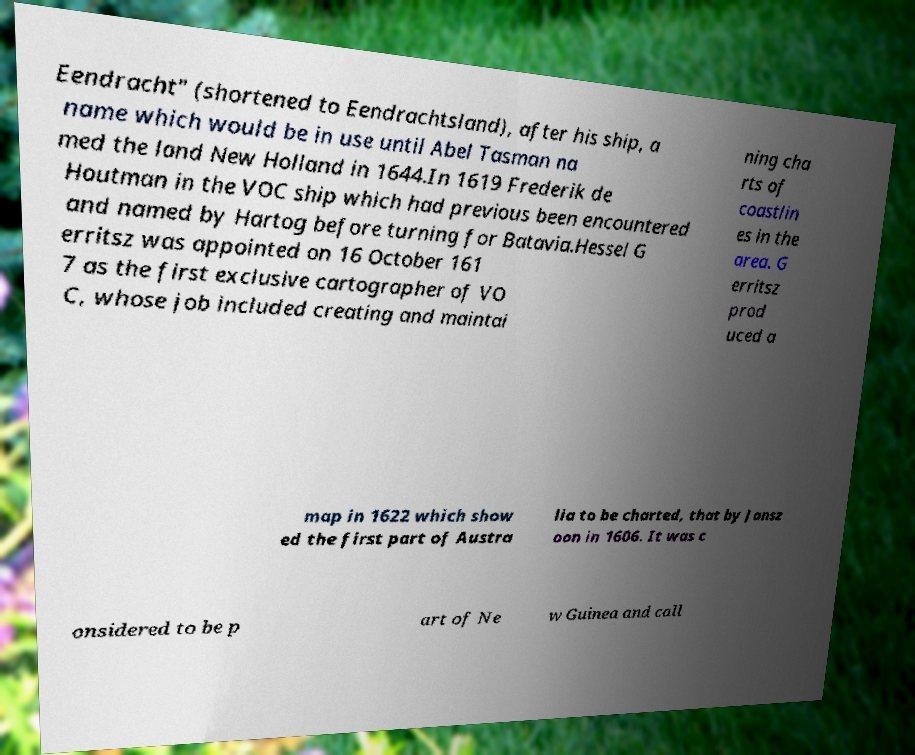For documentation purposes, I need the text within this image transcribed. Could you provide that? Eendracht" (shortened to Eendrachtsland), after his ship, a name which would be in use until Abel Tasman na med the land New Holland in 1644.In 1619 Frederik de Houtman in the VOC ship which had previous been encountered and named by Hartog before turning for Batavia.Hessel G erritsz was appointed on 16 October 161 7 as the first exclusive cartographer of VO C, whose job included creating and maintai ning cha rts of coastlin es in the area. G erritsz prod uced a map in 1622 which show ed the first part of Austra lia to be charted, that by Jansz oon in 1606. It was c onsidered to be p art of Ne w Guinea and call 